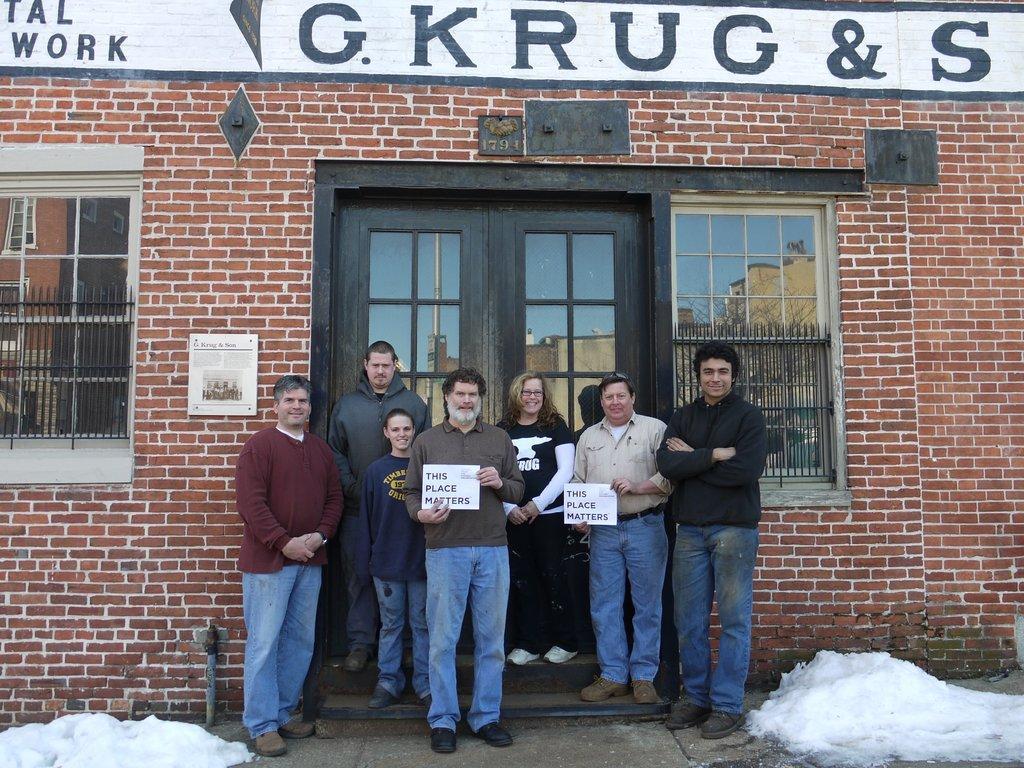Please provide a concise description of this image. In this image we can see some people standing and posing for a photo and two among them are holding a paper and we can see some text on that paper. In the background, we can see a building and there is a snow on the ground. 